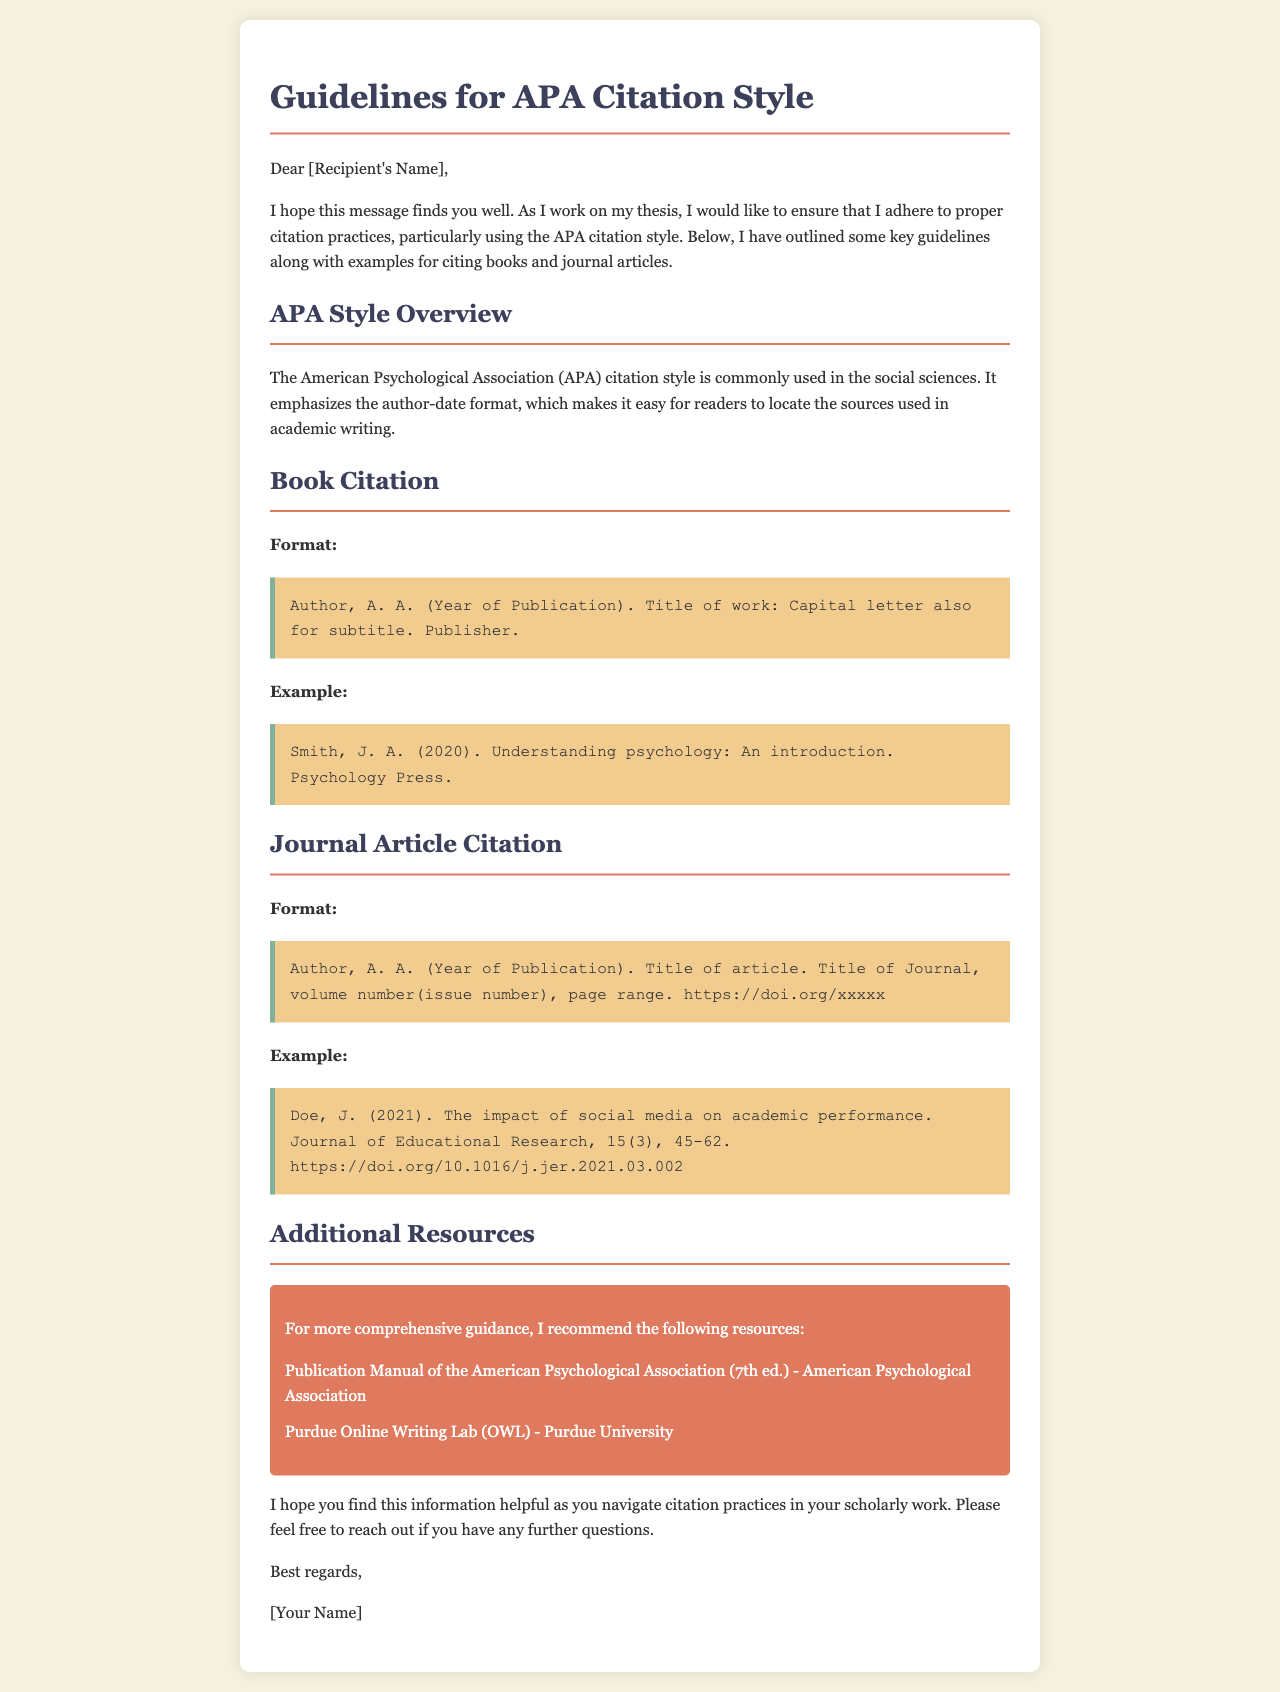what is the primary audience for APA citation style? The primary audience is specified as the social sciences, which is mentioned in the APA Style Overview section of the document.
Answer: social sciences who is the author of the example book citation? The author mentioned in the book citation example is J. A. Smith, as provided in the Book Citation section.
Answer: J. A. Smith what year was the example journal article published? The example journal article was published in 2021, as indicated in the Journal Article Citation section.
Answer: 2021 what is the title of the example journal article? The title of the example article is provided in the Journal Article Citation section, describing its focus on social media's impact on academic performance.
Answer: The impact of social media on academic performance how many resources are listed in the Additional Resources section? The document specifies two resources in the Additional Resources section for further guidance on APA citation practices.
Answer: 2 what is the publication year of the book in the example citation? The publication year for the book in the example citation is mentioned in the Book Citation section.
Answer: 2020 who can you contact for more questions according to the document? The document suggests reaching out to the author of the email for further questions.
Answer: [Your Name] what format is used for journal article citations in APA? The format specified in the document outlines the author-date citation style, with specific elements such as title, journal name, and page range.
Answer: Author, A. A. (Year of Publication). Title of article. Title of Journal, volume number(issue number), page range. https://doi.org/xxxxx 